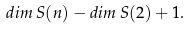<formula> <loc_0><loc_0><loc_500><loc_500>d i m \, S ( n ) - d i m \, S ( 2 ) + 1 .</formula> 